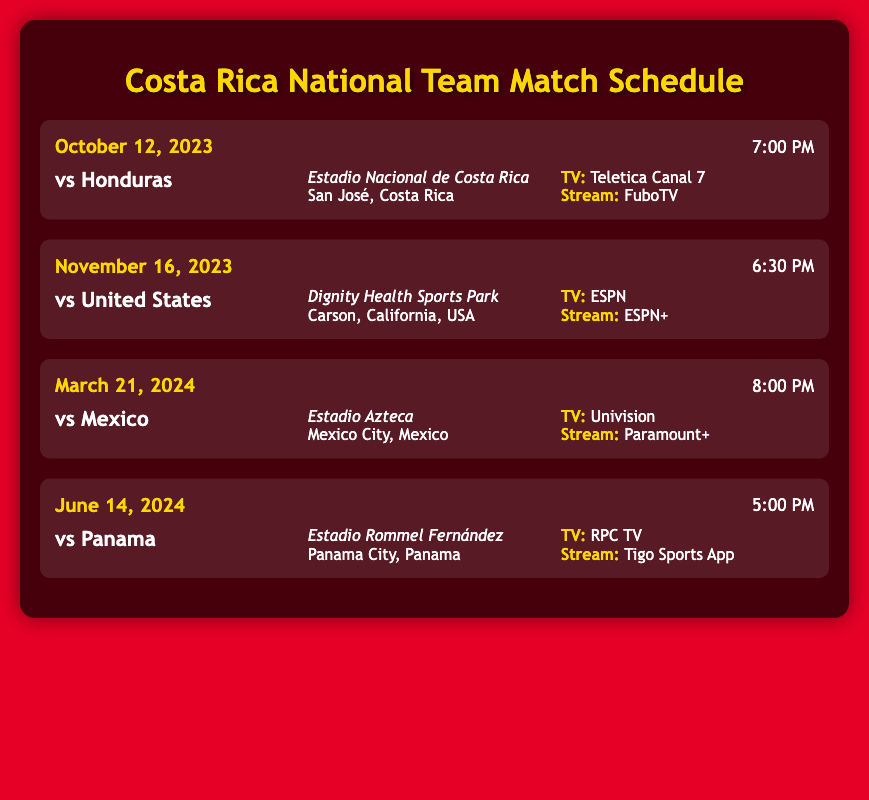What is the date of the match against Honduras? The match against Honduras is scheduled for October 12, 2023.
Answer: October 12, 2023 Where will the Costa Rica vs United States match take place? The Costa Rica vs United States match will be held at Dignity Health Sports Park.
Answer: Dignity Health Sports Park What time does the match against Mexico start? The match against Mexico starts at 8:00 PM.
Answer: 8:00 PM Which network will broadcast the match against Panama? The match against Panama will be broadcasted on RPC TV.
Answer: RPC TV How many matches are listed in the schedule? The schedule lists a total of four matches.
Answer: Four What is the venue for the match on March 21, 2024? The venue for the match on March 21, 2024 is Estadio Azteca.
Answer: Estadio Azteca Which streaming service offers the Costa Rica vs Honduras match? The Costa Rica vs Honduras match can be streamed on FuboTV.
Answer: FuboTV What is the opponent for the match on June 14, 2024? The opponent for the match on June 14, 2024 is Panama.
Answer: Panama 